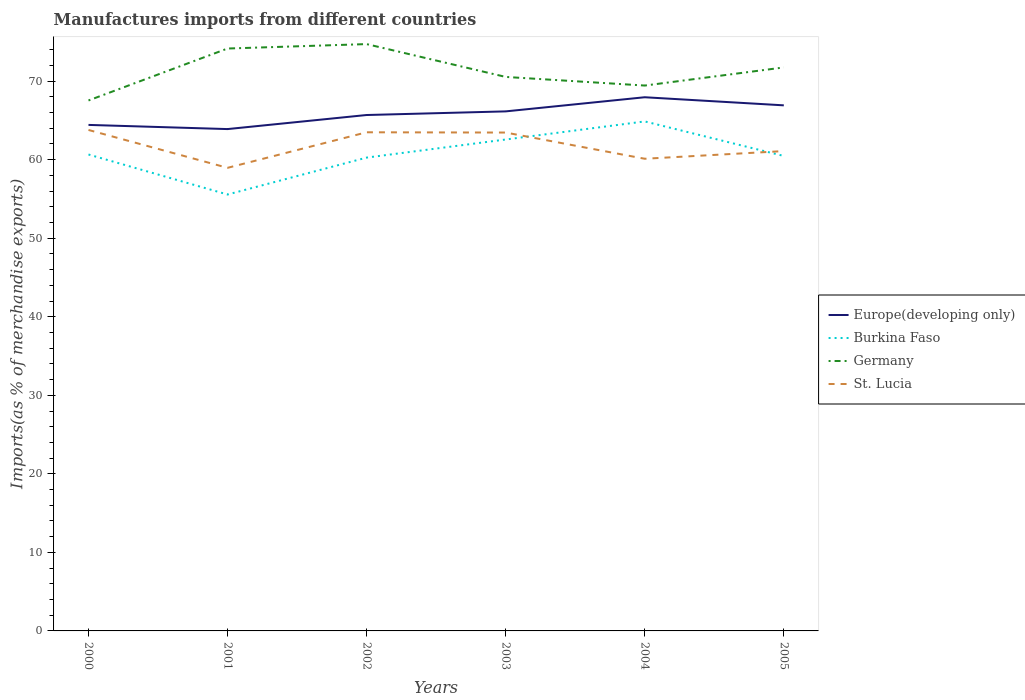How many different coloured lines are there?
Provide a succinct answer. 4. Does the line corresponding to Germany intersect with the line corresponding to Burkina Faso?
Offer a very short reply. No. Across all years, what is the maximum percentage of imports to different countries in St. Lucia?
Keep it short and to the point. 58.96. In which year was the percentage of imports to different countries in St. Lucia maximum?
Make the answer very short. 2001. What is the total percentage of imports to different countries in Germany in the graph?
Ensure brevity in your answer.  5.28. What is the difference between the highest and the second highest percentage of imports to different countries in Burkina Faso?
Ensure brevity in your answer.  9.31. Is the percentage of imports to different countries in Germany strictly greater than the percentage of imports to different countries in Burkina Faso over the years?
Provide a succinct answer. No. How many years are there in the graph?
Offer a terse response. 6. What is the difference between two consecutive major ticks on the Y-axis?
Keep it short and to the point. 10. Are the values on the major ticks of Y-axis written in scientific E-notation?
Your answer should be compact. No. How many legend labels are there?
Ensure brevity in your answer.  4. How are the legend labels stacked?
Keep it short and to the point. Vertical. What is the title of the graph?
Your answer should be very brief. Manufactures imports from different countries. What is the label or title of the X-axis?
Make the answer very short. Years. What is the label or title of the Y-axis?
Make the answer very short. Imports(as % of merchandise exports). What is the Imports(as % of merchandise exports) of Europe(developing only) in 2000?
Offer a terse response. 64.43. What is the Imports(as % of merchandise exports) in Burkina Faso in 2000?
Ensure brevity in your answer.  60.66. What is the Imports(as % of merchandise exports) in Germany in 2000?
Your answer should be compact. 67.54. What is the Imports(as % of merchandise exports) of St. Lucia in 2000?
Your response must be concise. 63.78. What is the Imports(as % of merchandise exports) of Europe(developing only) in 2001?
Your answer should be very brief. 63.9. What is the Imports(as % of merchandise exports) in Burkina Faso in 2001?
Provide a succinct answer. 55.56. What is the Imports(as % of merchandise exports) in Germany in 2001?
Your response must be concise. 74.15. What is the Imports(as % of merchandise exports) in St. Lucia in 2001?
Give a very brief answer. 58.96. What is the Imports(as % of merchandise exports) of Europe(developing only) in 2002?
Give a very brief answer. 65.69. What is the Imports(as % of merchandise exports) in Burkina Faso in 2002?
Make the answer very short. 60.26. What is the Imports(as % of merchandise exports) in Germany in 2002?
Offer a very short reply. 74.72. What is the Imports(as % of merchandise exports) of St. Lucia in 2002?
Your answer should be very brief. 63.49. What is the Imports(as % of merchandise exports) of Europe(developing only) in 2003?
Keep it short and to the point. 66.15. What is the Imports(as % of merchandise exports) of Burkina Faso in 2003?
Offer a terse response. 62.57. What is the Imports(as % of merchandise exports) of Germany in 2003?
Your answer should be compact. 70.54. What is the Imports(as % of merchandise exports) in St. Lucia in 2003?
Provide a short and direct response. 63.45. What is the Imports(as % of merchandise exports) of Europe(developing only) in 2004?
Offer a terse response. 67.95. What is the Imports(as % of merchandise exports) in Burkina Faso in 2004?
Give a very brief answer. 64.87. What is the Imports(as % of merchandise exports) in Germany in 2004?
Provide a short and direct response. 69.44. What is the Imports(as % of merchandise exports) of St. Lucia in 2004?
Give a very brief answer. 60.12. What is the Imports(as % of merchandise exports) of Europe(developing only) in 2005?
Your answer should be very brief. 66.92. What is the Imports(as % of merchandise exports) in Burkina Faso in 2005?
Keep it short and to the point. 60.47. What is the Imports(as % of merchandise exports) in Germany in 2005?
Make the answer very short. 71.74. What is the Imports(as % of merchandise exports) in St. Lucia in 2005?
Your answer should be compact. 61.1. Across all years, what is the maximum Imports(as % of merchandise exports) of Europe(developing only)?
Make the answer very short. 67.95. Across all years, what is the maximum Imports(as % of merchandise exports) of Burkina Faso?
Provide a short and direct response. 64.87. Across all years, what is the maximum Imports(as % of merchandise exports) in Germany?
Ensure brevity in your answer.  74.72. Across all years, what is the maximum Imports(as % of merchandise exports) of St. Lucia?
Give a very brief answer. 63.78. Across all years, what is the minimum Imports(as % of merchandise exports) of Europe(developing only)?
Provide a succinct answer. 63.9. Across all years, what is the minimum Imports(as % of merchandise exports) of Burkina Faso?
Your answer should be compact. 55.56. Across all years, what is the minimum Imports(as % of merchandise exports) of Germany?
Give a very brief answer. 67.54. Across all years, what is the minimum Imports(as % of merchandise exports) of St. Lucia?
Your response must be concise. 58.96. What is the total Imports(as % of merchandise exports) of Europe(developing only) in the graph?
Make the answer very short. 395.02. What is the total Imports(as % of merchandise exports) in Burkina Faso in the graph?
Your answer should be compact. 364.4. What is the total Imports(as % of merchandise exports) in Germany in the graph?
Ensure brevity in your answer.  428.13. What is the total Imports(as % of merchandise exports) in St. Lucia in the graph?
Provide a succinct answer. 370.9. What is the difference between the Imports(as % of merchandise exports) in Europe(developing only) in 2000 and that in 2001?
Your answer should be very brief. 0.53. What is the difference between the Imports(as % of merchandise exports) in Burkina Faso in 2000 and that in 2001?
Provide a succinct answer. 5.1. What is the difference between the Imports(as % of merchandise exports) of Germany in 2000 and that in 2001?
Your response must be concise. -6.61. What is the difference between the Imports(as % of merchandise exports) in St. Lucia in 2000 and that in 2001?
Offer a very short reply. 4.82. What is the difference between the Imports(as % of merchandise exports) of Europe(developing only) in 2000 and that in 2002?
Your answer should be compact. -1.26. What is the difference between the Imports(as % of merchandise exports) in Burkina Faso in 2000 and that in 2002?
Make the answer very short. 0.39. What is the difference between the Imports(as % of merchandise exports) of Germany in 2000 and that in 2002?
Ensure brevity in your answer.  -7.18. What is the difference between the Imports(as % of merchandise exports) in St. Lucia in 2000 and that in 2002?
Ensure brevity in your answer.  0.3. What is the difference between the Imports(as % of merchandise exports) in Europe(developing only) in 2000 and that in 2003?
Your answer should be very brief. -1.72. What is the difference between the Imports(as % of merchandise exports) in Burkina Faso in 2000 and that in 2003?
Offer a terse response. -1.91. What is the difference between the Imports(as % of merchandise exports) of Germany in 2000 and that in 2003?
Provide a succinct answer. -3. What is the difference between the Imports(as % of merchandise exports) of St. Lucia in 2000 and that in 2003?
Offer a very short reply. 0.33. What is the difference between the Imports(as % of merchandise exports) of Europe(developing only) in 2000 and that in 2004?
Your answer should be compact. -3.52. What is the difference between the Imports(as % of merchandise exports) in Burkina Faso in 2000 and that in 2004?
Offer a terse response. -4.21. What is the difference between the Imports(as % of merchandise exports) of Germany in 2000 and that in 2004?
Provide a succinct answer. -1.9. What is the difference between the Imports(as % of merchandise exports) in St. Lucia in 2000 and that in 2004?
Your answer should be compact. 3.67. What is the difference between the Imports(as % of merchandise exports) of Europe(developing only) in 2000 and that in 2005?
Your answer should be compact. -2.49. What is the difference between the Imports(as % of merchandise exports) in Burkina Faso in 2000 and that in 2005?
Ensure brevity in your answer.  0.19. What is the difference between the Imports(as % of merchandise exports) of Germany in 2000 and that in 2005?
Keep it short and to the point. -4.21. What is the difference between the Imports(as % of merchandise exports) of St. Lucia in 2000 and that in 2005?
Your answer should be very brief. 2.69. What is the difference between the Imports(as % of merchandise exports) of Europe(developing only) in 2001 and that in 2002?
Your response must be concise. -1.79. What is the difference between the Imports(as % of merchandise exports) in Burkina Faso in 2001 and that in 2002?
Provide a succinct answer. -4.7. What is the difference between the Imports(as % of merchandise exports) of Germany in 2001 and that in 2002?
Ensure brevity in your answer.  -0.56. What is the difference between the Imports(as % of merchandise exports) of St. Lucia in 2001 and that in 2002?
Keep it short and to the point. -4.53. What is the difference between the Imports(as % of merchandise exports) of Europe(developing only) in 2001 and that in 2003?
Offer a terse response. -2.25. What is the difference between the Imports(as % of merchandise exports) in Burkina Faso in 2001 and that in 2003?
Provide a short and direct response. -7. What is the difference between the Imports(as % of merchandise exports) of Germany in 2001 and that in 2003?
Your answer should be compact. 3.62. What is the difference between the Imports(as % of merchandise exports) of St. Lucia in 2001 and that in 2003?
Your response must be concise. -4.49. What is the difference between the Imports(as % of merchandise exports) of Europe(developing only) in 2001 and that in 2004?
Make the answer very short. -4.05. What is the difference between the Imports(as % of merchandise exports) in Burkina Faso in 2001 and that in 2004?
Keep it short and to the point. -9.31. What is the difference between the Imports(as % of merchandise exports) of Germany in 2001 and that in 2004?
Provide a succinct answer. 4.71. What is the difference between the Imports(as % of merchandise exports) of St. Lucia in 2001 and that in 2004?
Your answer should be very brief. -1.16. What is the difference between the Imports(as % of merchandise exports) of Europe(developing only) in 2001 and that in 2005?
Your response must be concise. -3.02. What is the difference between the Imports(as % of merchandise exports) in Burkina Faso in 2001 and that in 2005?
Your answer should be compact. -4.91. What is the difference between the Imports(as % of merchandise exports) in Germany in 2001 and that in 2005?
Keep it short and to the point. 2.41. What is the difference between the Imports(as % of merchandise exports) in St. Lucia in 2001 and that in 2005?
Provide a succinct answer. -2.13. What is the difference between the Imports(as % of merchandise exports) of Europe(developing only) in 2002 and that in 2003?
Your answer should be compact. -0.46. What is the difference between the Imports(as % of merchandise exports) of Burkina Faso in 2002 and that in 2003?
Give a very brief answer. -2.3. What is the difference between the Imports(as % of merchandise exports) of Germany in 2002 and that in 2003?
Offer a very short reply. 4.18. What is the difference between the Imports(as % of merchandise exports) of St. Lucia in 2002 and that in 2003?
Offer a very short reply. 0.03. What is the difference between the Imports(as % of merchandise exports) of Europe(developing only) in 2002 and that in 2004?
Provide a succinct answer. -2.26. What is the difference between the Imports(as % of merchandise exports) in Burkina Faso in 2002 and that in 2004?
Provide a succinct answer. -4.61. What is the difference between the Imports(as % of merchandise exports) of Germany in 2002 and that in 2004?
Offer a very short reply. 5.28. What is the difference between the Imports(as % of merchandise exports) of St. Lucia in 2002 and that in 2004?
Offer a very short reply. 3.37. What is the difference between the Imports(as % of merchandise exports) of Europe(developing only) in 2002 and that in 2005?
Your answer should be compact. -1.23. What is the difference between the Imports(as % of merchandise exports) in Burkina Faso in 2002 and that in 2005?
Ensure brevity in your answer.  -0.21. What is the difference between the Imports(as % of merchandise exports) of Germany in 2002 and that in 2005?
Provide a succinct answer. 2.97. What is the difference between the Imports(as % of merchandise exports) in St. Lucia in 2002 and that in 2005?
Your answer should be compact. 2.39. What is the difference between the Imports(as % of merchandise exports) of Europe(developing only) in 2003 and that in 2004?
Give a very brief answer. -1.8. What is the difference between the Imports(as % of merchandise exports) in Burkina Faso in 2003 and that in 2004?
Make the answer very short. -2.3. What is the difference between the Imports(as % of merchandise exports) in Germany in 2003 and that in 2004?
Offer a very short reply. 1.1. What is the difference between the Imports(as % of merchandise exports) of St. Lucia in 2003 and that in 2004?
Your answer should be very brief. 3.34. What is the difference between the Imports(as % of merchandise exports) in Europe(developing only) in 2003 and that in 2005?
Your answer should be compact. -0.77. What is the difference between the Imports(as % of merchandise exports) of Burkina Faso in 2003 and that in 2005?
Give a very brief answer. 2.09. What is the difference between the Imports(as % of merchandise exports) of Germany in 2003 and that in 2005?
Provide a succinct answer. -1.21. What is the difference between the Imports(as % of merchandise exports) of St. Lucia in 2003 and that in 2005?
Offer a terse response. 2.36. What is the difference between the Imports(as % of merchandise exports) of Europe(developing only) in 2004 and that in 2005?
Your answer should be very brief. 1.03. What is the difference between the Imports(as % of merchandise exports) in Burkina Faso in 2004 and that in 2005?
Offer a terse response. 4.4. What is the difference between the Imports(as % of merchandise exports) of Germany in 2004 and that in 2005?
Your answer should be compact. -2.31. What is the difference between the Imports(as % of merchandise exports) of St. Lucia in 2004 and that in 2005?
Offer a terse response. -0.98. What is the difference between the Imports(as % of merchandise exports) of Europe(developing only) in 2000 and the Imports(as % of merchandise exports) of Burkina Faso in 2001?
Your answer should be compact. 8.86. What is the difference between the Imports(as % of merchandise exports) of Europe(developing only) in 2000 and the Imports(as % of merchandise exports) of Germany in 2001?
Provide a short and direct response. -9.73. What is the difference between the Imports(as % of merchandise exports) of Europe(developing only) in 2000 and the Imports(as % of merchandise exports) of St. Lucia in 2001?
Give a very brief answer. 5.47. What is the difference between the Imports(as % of merchandise exports) of Burkina Faso in 2000 and the Imports(as % of merchandise exports) of Germany in 2001?
Give a very brief answer. -13.49. What is the difference between the Imports(as % of merchandise exports) in Burkina Faso in 2000 and the Imports(as % of merchandise exports) in St. Lucia in 2001?
Ensure brevity in your answer.  1.7. What is the difference between the Imports(as % of merchandise exports) of Germany in 2000 and the Imports(as % of merchandise exports) of St. Lucia in 2001?
Keep it short and to the point. 8.58. What is the difference between the Imports(as % of merchandise exports) in Europe(developing only) in 2000 and the Imports(as % of merchandise exports) in Burkina Faso in 2002?
Your answer should be compact. 4.16. What is the difference between the Imports(as % of merchandise exports) of Europe(developing only) in 2000 and the Imports(as % of merchandise exports) of Germany in 2002?
Offer a very short reply. -10.29. What is the difference between the Imports(as % of merchandise exports) in Europe(developing only) in 2000 and the Imports(as % of merchandise exports) in St. Lucia in 2002?
Ensure brevity in your answer.  0.94. What is the difference between the Imports(as % of merchandise exports) in Burkina Faso in 2000 and the Imports(as % of merchandise exports) in Germany in 2002?
Keep it short and to the point. -14.06. What is the difference between the Imports(as % of merchandise exports) in Burkina Faso in 2000 and the Imports(as % of merchandise exports) in St. Lucia in 2002?
Give a very brief answer. -2.83. What is the difference between the Imports(as % of merchandise exports) in Germany in 2000 and the Imports(as % of merchandise exports) in St. Lucia in 2002?
Your response must be concise. 4.05. What is the difference between the Imports(as % of merchandise exports) in Europe(developing only) in 2000 and the Imports(as % of merchandise exports) in Burkina Faso in 2003?
Give a very brief answer. 1.86. What is the difference between the Imports(as % of merchandise exports) in Europe(developing only) in 2000 and the Imports(as % of merchandise exports) in Germany in 2003?
Give a very brief answer. -6.11. What is the difference between the Imports(as % of merchandise exports) in Europe(developing only) in 2000 and the Imports(as % of merchandise exports) in St. Lucia in 2003?
Give a very brief answer. 0.97. What is the difference between the Imports(as % of merchandise exports) of Burkina Faso in 2000 and the Imports(as % of merchandise exports) of Germany in 2003?
Provide a succinct answer. -9.88. What is the difference between the Imports(as % of merchandise exports) in Burkina Faso in 2000 and the Imports(as % of merchandise exports) in St. Lucia in 2003?
Provide a short and direct response. -2.79. What is the difference between the Imports(as % of merchandise exports) in Germany in 2000 and the Imports(as % of merchandise exports) in St. Lucia in 2003?
Ensure brevity in your answer.  4.08. What is the difference between the Imports(as % of merchandise exports) of Europe(developing only) in 2000 and the Imports(as % of merchandise exports) of Burkina Faso in 2004?
Ensure brevity in your answer.  -0.44. What is the difference between the Imports(as % of merchandise exports) of Europe(developing only) in 2000 and the Imports(as % of merchandise exports) of Germany in 2004?
Offer a very short reply. -5.01. What is the difference between the Imports(as % of merchandise exports) of Europe(developing only) in 2000 and the Imports(as % of merchandise exports) of St. Lucia in 2004?
Offer a terse response. 4.31. What is the difference between the Imports(as % of merchandise exports) in Burkina Faso in 2000 and the Imports(as % of merchandise exports) in Germany in 2004?
Your answer should be compact. -8.78. What is the difference between the Imports(as % of merchandise exports) of Burkina Faso in 2000 and the Imports(as % of merchandise exports) of St. Lucia in 2004?
Your answer should be very brief. 0.54. What is the difference between the Imports(as % of merchandise exports) of Germany in 2000 and the Imports(as % of merchandise exports) of St. Lucia in 2004?
Ensure brevity in your answer.  7.42. What is the difference between the Imports(as % of merchandise exports) in Europe(developing only) in 2000 and the Imports(as % of merchandise exports) in Burkina Faso in 2005?
Offer a terse response. 3.95. What is the difference between the Imports(as % of merchandise exports) of Europe(developing only) in 2000 and the Imports(as % of merchandise exports) of Germany in 2005?
Make the answer very short. -7.32. What is the difference between the Imports(as % of merchandise exports) of Europe(developing only) in 2000 and the Imports(as % of merchandise exports) of St. Lucia in 2005?
Keep it short and to the point. 3.33. What is the difference between the Imports(as % of merchandise exports) of Burkina Faso in 2000 and the Imports(as % of merchandise exports) of Germany in 2005?
Offer a terse response. -11.09. What is the difference between the Imports(as % of merchandise exports) of Burkina Faso in 2000 and the Imports(as % of merchandise exports) of St. Lucia in 2005?
Provide a succinct answer. -0.44. What is the difference between the Imports(as % of merchandise exports) in Germany in 2000 and the Imports(as % of merchandise exports) in St. Lucia in 2005?
Keep it short and to the point. 6.44. What is the difference between the Imports(as % of merchandise exports) in Europe(developing only) in 2001 and the Imports(as % of merchandise exports) in Burkina Faso in 2002?
Provide a succinct answer. 3.63. What is the difference between the Imports(as % of merchandise exports) in Europe(developing only) in 2001 and the Imports(as % of merchandise exports) in Germany in 2002?
Keep it short and to the point. -10.82. What is the difference between the Imports(as % of merchandise exports) of Europe(developing only) in 2001 and the Imports(as % of merchandise exports) of St. Lucia in 2002?
Your answer should be very brief. 0.41. What is the difference between the Imports(as % of merchandise exports) of Burkina Faso in 2001 and the Imports(as % of merchandise exports) of Germany in 2002?
Your answer should be very brief. -19.15. What is the difference between the Imports(as % of merchandise exports) of Burkina Faso in 2001 and the Imports(as % of merchandise exports) of St. Lucia in 2002?
Provide a succinct answer. -7.92. What is the difference between the Imports(as % of merchandise exports) of Germany in 2001 and the Imports(as % of merchandise exports) of St. Lucia in 2002?
Give a very brief answer. 10.66. What is the difference between the Imports(as % of merchandise exports) of Europe(developing only) in 2001 and the Imports(as % of merchandise exports) of Burkina Faso in 2003?
Your answer should be very brief. 1.33. What is the difference between the Imports(as % of merchandise exports) in Europe(developing only) in 2001 and the Imports(as % of merchandise exports) in Germany in 2003?
Your response must be concise. -6.64. What is the difference between the Imports(as % of merchandise exports) of Europe(developing only) in 2001 and the Imports(as % of merchandise exports) of St. Lucia in 2003?
Provide a succinct answer. 0.44. What is the difference between the Imports(as % of merchandise exports) of Burkina Faso in 2001 and the Imports(as % of merchandise exports) of Germany in 2003?
Your answer should be compact. -14.97. What is the difference between the Imports(as % of merchandise exports) of Burkina Faso in 2001 and the Imports(as % of merchandise exports) of St. Lucia in 2003?
Provide a short and direct response. -7.89. What is the difference between the Imports(as % of merchandise exports) in Germany in 2001 and the Imports(as % of merchandise exports) in St. Lucia in 2003?
Ensure brevity in your answer.  10.7. What is the difference between the Imports(as % of merchandise exports) in Europe(developing only) in 2001 and the Imports(as % of merchandise exports) in Burkina Faso in 2004?
Offer a terse response. -0.97. What is the difference between the Imports(as % of merchandise exports) of Europe(developing only) in 2001 and the Imports(as % of merchandise exports) of Germany in 2004?
Offer a very short reply. -5.54. What is the difference between the Imports(as % of merchandise exports) of Europe(developing only) in 2001 and the Imports(as % of merchandise exports) of St. Lucia in 2004?
Offer a very short reply. 3.78. What is the difference between the Imports(as % of merchandise exports) in Burkina Faso in 2001 and the Imports(as % of merchandise exports) in Germany in 2004?
Your answer should be compact. -13.87. What is the difference between the Imports(as % of merchandise exports) in Burkina Faso in 2001 and the Imports(as % of merchandise exports) in St. Lucia in 2004?
Your answer should be very brief. -4.55. What is the difference between the Imports(as % of merchandise exports) of Germany in 2001 and the Imports(as % of merchandise exports) of St. Lucia in 2004?
Make the answer very short. 14.04. What is the difference between the Imports(as % of merchandise exports) of Europe(developing only) in 2001 and the Imports(as % of merchandise exports) of Burkina Faso in 2005?
Offer a terse response. 3.42. What is the difference between the Imports(as % of merchandise exports) of Europe(developing only) in 2001 and the Imports(as % of merchandise exports) of Germany in 2005?
Your answer should be very brief. -7.85. What is the difference between the Imports(as % of merchandise exports) in Europe(developing only) in 2001 and the Imports(as % of merchandise exports) in St. Lucia in 2005?
Offer a very short reply. 2.8. What is the difference between the Imports(as % of merchandise exports) in Burkina Faso in 2001 and the Imports(as % of merchandise exports) in Germany in 2005?
Provide a succinct answer. -16.18. What is the difference between the Imports(as % of merchandise exports) of Burkina Faso in 2001 and the Imports(as % of merchandise exports) of St. Lucia in 2005?
Give a very brief answer. -5.53. What is the difference between the Imports(as % of merchandise exports) of Germany in 2001 and the Imports(as % of merchandise exports) of St. Lucia in 2005?
Ensure brevity in your answer.  13.06. What is the difference between the Imports(as % of merchandise exports) in Europe(developing only) in 2002 and the Imports(as % of merchandise exports) in Burkina Faso in 2003?
Your answer should be very brief. 3.12. What is the difference between the Imports(as % of merchandise exports) in Europe(developing only) in 2002 and the Imports(as % of merchandise exports) in Germany in 2003?
Make the answer very short. -4.85. What is the difference between the Imports(as % of merchandise exports) of Europe(developing only) in 2002 and the Imports(as % of merchandise exports) of St. Lucia in 2003?
Ensure brevity in your answer.  2.23. What is the difference between the Imports(as % of merchandise exports) of Burkina Faso in 2002 and the Imports(as % of merchandise exports) of Germany in 2003?
Offer a very short reply. -10.27. What is the difference between the Imports(as % of merchandise exports) in Burkina Faso in 2002 and the Imports(as % of merchandise exports) in St. Lucia in 2003?
Provide a succinct answer. -3.19. What is the difference between the Imports(as % of merchandise exports) of Germany in 2002 and the Imports(as % of merchandise exports) of St. Lucia in 2003?
Provide a succinct answer. 11.26. What is the difference between the Imports(as % of merchandise exports) in Europe(developing only) in 2002 and the Imports(as % of merchandise exports) in Burkina Faso in 2004?
Your answer should be compact. 0.82. What is the difference between the Imports(as % of merchandise exports) in Europe(developing only) in 2002 and the Imports(as % of merchandise exports) in Germany in 2004?
Make the answer very short. -3.75. What is the difference between the Imports(as % of merchandise exports) in Europe(developing only) in 2002 and the Imports(as % of merchandise exports) in St. Lucia in 2004?
Offer a very short reply. 5.57. What is the difference between the Imports(as % of merchandise exports) of Burkina Faso in 2002 and the Imports(as % of merchandise exports) of Germany in 2004?
Keep it short and to the point. -9.17. What is the difference between the Imports(as % of merchandise exports) in Burkina Faso in 2002 and the Imports(as % of merchandise exports) in St. Lucia in 2004?
Offer a terse response. 0.15. What is the difference between the Imports(as % of merchandise exports) in Germany in 2002 and the Imports(as % of merchandise exports) in St. Lucia in 2004?
Provide a short and direct response. 14.6. What is the difference between the Imports(as % of merchandise exports) in Europe(developing only) in 2002 and the Imports(as % of merchandise exports) in Burkina Faso in 2005?
Offer a very short reply. 5.21. What is the difference between the Imports(as % of merchandise exports) of Europe(developing only) in 2002 and the Imports(as % of merchandise exports) of Germany in 2005?
Your answer should be very brief. -6.06. What is the difference between the Imports(as % of merchandise exports) of Europe(developing only) in 2002 and the Imports(as % of merchandise exports) of St. Lucia in 2005?
Provide a succinct answer. 4.59. What is the difference between the Imports(as % of merchandise exports) of Burkina Faso in 2002 and the Imports(as % of merchandise exports) of Germany in 2005?
Your answer should be very brief. -11.48. What is the difference between the Imports(as % of merchandise exports) of Burkina Faso in 2002 and the Imports(as % of merchandise exports) of St. Lucia in 2005?
Make the answer very short. -0.83. What is the difference between the Imports(as % of merchandise exports) in Germany in 2002 and the Imports(as % of merchandise exports) in St. Lucia in 2005?
Make the answer very short. 13.62. What is the difference between the Imports(as % of merchandise exports) of Europe(developing only) in 2003 and the Imports(as % of merchandise exports) of Burkina Faso in 2004?
Make the answer very short. 1.28. What is the difference between the Imports(as % of merchandise exports) in Europe(developing only) in 2003 and the Imports(as % of merchandise exports) in Germany in 2004?
Your response must be concise. -3.29. What is the difference between the Imports(as % of merchandise exports) in Europe(developing only) in 2003 and the Imports(as % of merchandise exports) in St. Lucia in 2004?
Give a very brief answer. 6.03. What is the difference between the Imports(as % of merchandise exports) of Burkina Faso in 2003 and the Imports(as % of merchandise exports) of Germany in 2004?
Your answer should be compact. -6.87. What is the difference between the Imports(as % of merchandise exports) in Burkina Faso in 2003 and the Imports(as % of merchandise exports) in St. Lucia in 2004?
Provide a succinct answer. 2.45. What is the difference between the Imports(as % of merchandise exports) of Germany in 2003 and the Imports(as % of merchandise exports) of St. Lucia in 2004?
Ensure brevity in your answer.  10.42. What is the difference between the Imports(as % of merchandise exports) of Europe(developing only) in 2003 and the Imports(as % of merchandise exports) of Burkina Faso in 2005?
Your answer should be very brief. 5.67. What is the difference between the Imports(as % of merchandise exports) of Europe(developing only) in 2003 and the Imports(as % of merchandise exports) of Germany in 2005?
Your answer should be very brief. -5.6. What is the difference between the Imports(as % of merchandise exports) of Europe(developing only) in 2003 and the Imports(as % of merchandise exports) of St. Lucia in 2005?
Offer a very short reply. 5.05. What is the difference between the Imports(as % of merchandise exports) in Burkina Faso in 2003 and the Imports(as % of merchandise exports) in Germany in 2005?
Make the answer very short. -9.18. What is the difference between the Imports(as % of merchandise exports) of Burkina Faso in 2003 and the Imports(as % of merchandise exports) of St. Lucia in 2005?
Provide a short and direct response. 1.47. What is the difference between the Imports(as % of merchandise exports) of Germany in 2003 and the Imports(as % of merchandise exports) of St. Lucia in 2005?
Your answer should be compact. 9.44. What is the difference between the Imports(as % of merchandise exports) of Europe(developing only) in 2004 and the Imports(as % of merchandise exports) of Burkina Faso in 2005?
Offer a terse response. 7.47. What is the difference between the Imports(as % of merchandise exports) of Europe(developing only) in 2004 and the Imports(as % of merchandise exports) of Germany in 2005?
Keep it short and to the point. -3.8. What is the difference between the Imports(as % of merchandise exports) in Europe(developing only) in 2004 and the Imports(as % of merchandise exports) in St. Lucia in 2005?
Keep it short and to the point. 6.85. What is the difference between the Imports(as % of merchandise exports) of Burkina Faso in 2004 and the Imports(as % of merchandise exports) of Germany in 2005?
Provide a short and direct response. -6.87. What is the difference between the Imports(as % of merchandise exports) of Burkina Faso in 2004 and the Imports(as % of merchandise exports) of St. Lucia in 2005?
Your response must be concise. 3.78. What is the difference between the Imports(as % of merchandise exports) of Germany in 2004 and the Imports(as % of merchandise exports) of St. Lucia in 2005?
Ensure brevity in your answer.  8.34. What is the average Imports(as % of merchandise exports) in Europe(developing only) per year?
Your answer should be compact. 65.84. What is the average Imports(as % of merchandise exports) of Burkina Faso per year?
Offer a terse response. 60.73. What is the average Imports(as % of merchandise exports) of Germany per year?
Provide a succinct answer. 71.35. What is the average Imports(as % of merchandise exports) in St. Lucia per year?
Make the answer very short. 61.82. In the year 2000, what is the difference between the Imports(as % of merchandise exports) in Europe(developing only) and Imports(as % of merchandise exports) in Burkina Faso?
Ensure brevity in your answer.  3.77. In the year 2000, what is the difference between the Imports(as % of merchandise exports) in Europe(developing only) and Imports(as % of merchandise exports) in Germany?
Provide a succinct answer. -3.11. In the year 2000, what is the difference between the Imports(as % of merchandise exports) of Europe(developing only) and Imports(as % of merchandise exports) of St. Lucia?
Your response must be concise. 0.64. In the year 2000, what is the difference between the Imports(as % of merchandise exports) in Burkina Faso and Imports(as % of merchandise exports) in Germany?
Keep it short and to the point. -6.88. In the year 2000, what is the difference between the Imports(as % of merchandise exports) in Burkina Faso and Imports(as % of merchandise exports) in St. Lucia?
Offer a terse response. -3.12. In the year 2000, what is the difference between the Imports(as % of merchandise exports) of Germany and Imports(as % of merchandise exports) of St. Lucia?
Provide a succinct answer. 3.75. In the year 2001, what is the difference between the Imports(as % of merchandise exports) in Europe(developing only) and Imports(as % of merchandise exports) in Burkina Faso?
Your answer should be very brief. 8.33. In the year 2001, what is the difference between the Imports(as % of merchandise exports) of Europe(developing only) and Imports(as % of merchandise exports) of Germany?
Your response must be concise. -10.26. In the year 2001, what is the difference between the Imports(as % of merchandise exports) in Europe(developing only) and Imports(as % of merchandise exports) in St. Lucia?
Ensure brevity in your answer.  4.93. In the year 2001, what is the difference between the Imports(as % of merchandise exports) of Burkina Faso and Imports(as % of merchandise exports) of Germany?
Make the answer very short. -18.59. In the year 2001, what is the difference between the Imports(as % of merchandise exports) in Burkina Faso and Imports(as % of merchandise exports) in St. Lucia?
Offer a terse response. -3.4. In the year 2001, what is the difference between the Imports(as % of merchandise exports) of Germany and Imports(as % of merchandise exports) of St. Lucia?
Give a very brief answer. 15.19. In the year 2002, what is the difference between the Imports(as % of merchandise exports) of Europe(developing only) and Imports(as % of merchandise exports) of Burkina Faso?
Offer a terse response. 5.42. In the year 2002, what is the difference between the Imports(as % of merchandise exports) in Europe(developing only) and Imports(as % of merchandise exports) in Germany?
Keep it short and to the point. -9.03. In the year 2002, what is the difference between the Imports(as % of merchandise exports) of Europe(developing only) and Imports(as % of merchandise exports) of St. Lucia?
Ensure brevity in your answer.  2.2. In the year 2002, what is the difference between the Imports(as % of merchandise exports) in Burkina Faso and Imports(as % of merchandise exports) in Germany?
Your response must be concise. -14.45. In the year 2002, what is the difference between the Imports(as % of merchandise exports) in Burkina Faso and Imports(as % of merchandise exports) in St. Lucia?
Give a very brief answer. -3.22. In the year 2002, what is the difference between the Imports(as % of merchandise exports) in Germany and Imports(as % of merchandise exports) in St. Lucia?
Ensure brevity in your answer.  11.23. In the year 2003, what is the difference between the Imports(as % of merchandise exports) in Europe(developing only) and Imports(as % of merchandise exports) in Burkina Faso?
Ensure brevity in your answer.  3.58. In the year 2003, what is the difference between the Imports(as % of merchandise exports) in Europe(developing only) and Imports(as % of merchandise exports) in Germany?
Offer a terse response. -4.39. In the year 2003, what is the difference between the Imports(as % of merchandise exports) of Europe(developing only) and Imports(as % of merchandise exports) of St. Lucia?
Offer a terse response. 2.69. In the year 2003, what is the difference between the Imports(as % of merchandise exports) of Burkina Faso and Imports(as % of merchandise exports) of Germany?
Give a very brief answer. -7.97. In the year 2003, what is the difference between the Imports(as % of merchandise exports) of Burkina Faso and Imports(as % of merchandise exports) of St. Lucia?
Keep it short and to the point. -0.89. In the year 2003, what is the difference between the Imports(as % of merchandise exports) of Germany and Imports(as % of merchandise exports) of St. Lucia?
Offer a very short reply. 7.08. In the year 2004, what is the difference between the Imports(as % of merchandise exports) in Europe(developing only) and Imports(as % of merchandise exports) in Burkina Faso?
Give a very brief answer. 3.08. In the year 2004, what is the difference between the Imports(as % of merchandise exports) in Europe(developing only) and Imports(as % of merchandise exports) in Germany?
Ensure brevity in your answer.  -1.49. In the year 2004, what is the difference between the Imports(as % of merchandise exports) in Europe(developing only) and Imports(as % of merchandise exports) in St. Lucia?
Keep it short and to the point. 7.83. In the year 2004, what is the difference between the Imports(as % of merchandise exports) in Burkina Faso and Imports(as % of merchandise exports) in Germany?
Give a very brief answer. -4.57. In the year 2004, what is the difference between the Imports(as % of merchandise exports) of Burkina Faso and Imports(as % of merchandise exports) of St. Lucia?
Keep it short and to the point. 4.75. In the year 2004, what is the difference between the Imports(as % of merchandise exports) in Germany and Imports(as % of merchandise exports) in St. Lucia?
Keep it short and to the point. 9.32. In the year 2005, what is the difference between the Imports(as % of merchandise exports) in Europe(developing only) and Imports(as % of merchandise exports) in Burkina Faso?
Give a very brief answer. 6.44. In the year 2005, what is the difference between the Imports(as % of merchandise exports) in Europe(developing only) and Imports(as % of merchandise exports) in Germany?
Ensure brevity in your answer.  -4.83. In the year 2005, what is the difference between the Imports(as % of merchandise exports) in Europe(developing only) and Imports(as % of merchandise exports) in St. Lucia?
Offer a terse response. 5.82. In the year 2005, what is the difference between the Imports(as % of merchandise exports) in Burkina Faso and Imports(as % of merchandise exports) in Germany?
Make the answer very short. -11.27. In the year 2005, what is the difference between the Imports(as % of merchandise exports) of Burkina Faso and Imports(as % of merchandise exports) of St. Lucia?
Keep it short and to the point. -0.62. In the year 2005, what is the difference between the Imports(as % of merchandise exports) in Germany and Imports(as % of merchandise exports) in St. Lucia?
Your answer should be compact. 10.65. What is the ratio of the Imports(as % of merchandise exports) in Europe(developing only) in 2000 to that in 2001?
Offer a very short reply. 1.01. What is the ratio of the Imports(as % of merchandise exports) in Burkina Faso in 2000 to that in 2001?
Offer a very short reply. 1.09. What is the ratio of the Imports(as % of merchandise exports) in Germany in 2000 to that in 2001?
Offer a terse response. 0.91. What is the ratio of the Imports(as % of merchandise exports) of St. Lucia in 2000 to that in 2001?
Offer a very short reply. 1.08. What is the ratio of the Imports(as % of merchandise exports) in Europe(developing only) in 2000 to that in 2002?
Offer a terse response. 0.98. What is the ratio of the Imports(as % of merchandise exports) in Burkina Faso in 2000 to that in 2002?
Offer a terse response. 1.01. What is the ratio of the Imports(as % of merchandise exports) in Germany in 2000 to that in 2002?
Offer a terse response. 0.9. What is the ratio of the Imports(as % of merchandise exports) of Burkina Faso in 2000 to that in 2003?
Ensure brevity in your answer.  0.97. What is the ratio of the Imports(as % of merchandise exports) of Germany in 2000 to that in 2003?
Offer a terse response. 0.96. What is the ratio of the Imports(as % of merchandise exports) in Europe(developing only) in 2000 to that in 2004?
Provide a short and direct response. 0.95. What is the ratio of the Imports(as % of merchandise exports) of Burkina Faso in 2000 to that in 2004?
Your response must be concise. 0.94. What is the ratio of the Imports(as % of merchandise exports) of Germany in 2000 to that in 2004?
Your response must be concise. 0.97. What is the ratio of the Imports(as % of merchandise exports) of St. Lucia in 2000 to that in 2004?
Offer a terse response. 1.06. What is the ratio of the Imports(as % of merchandise exports) of Europe(developing only) in 2000 to that in 2005?
Provide a succinct answer. 0.96. What is the ratio of the Imports(as % of merchandise exports) in Germany in 2000 to that in 2005?
Offer a terse response. 0.94. What is the ratio of the Imports(as % of merchandise exports) in St. Lucia in 2000 to that in 2005?
Your answer should be compact. 1.04. What is the ratio of the Imports(as % of merchandise exports) in Europe(developing only) in 2001 to that in 2002?
Provide a succinct answer. 0.97. What is the ratio of the Imports(as % of merchandise exports) of Burkina Faso in 2001 to that in 2002?
Your answer should be very brief. 0.92. What is the ratio of the Imports(as % of merchandise exports) in Germany in 2001 to that in 2002?
Your response must be concise. 0.99. What is the ratio of the Imports(as % of merchandise exports) in St. Lucia in 2001 to that in 2002?
Provide a short and direct response. 0.93. What is the ratio of the Imports(as % of merchandise exports) in Europe(developing only) in 2001 to that in 2003?
Your answer should be very brief. 0.97. What is the ratio of the Imports(as % of merchandise exports) in Burkina Faso in 2001 to that in 2003?
Ensure brevity in your answer.  0.89. What is the ratio of the Imports(as % of merchandise exports) in Germany in 2001 to that in 2003?
Ensure brevity in your answer.  1.05. What is the ratio of the Imports(as % of merchandise exports) in St. Lucia in 2001 to that in 2003?
Give a very brief answer. 0.93. What is the ratio of the Imports(as % of merchandise exports) in Europe(developing only) in 2001 to that in 2004?
Make the answer very short. 0.94. What is the ratio of the Imports(as % of merchandise exports) of Burkina Faso in 2001 to that in 2004?
Make the answer very short. 0.86. What is the ratio of the Imports(as % of merchandise exports) in Germany in 2001 to that in 2004?
Your response must be concise. 1.07. What is the ratio of the Imports(as % of merchandise exports) in St. Lucia in 2001 to that in 2004?
Provide a short and direct response. 0.98. What is the ratio of the Imports(as % of merchandise exports) in Europe(developing only) in 2001 to that in 2005?
Your answer should be compact. 0.95. What is the ratio of the Imports(as % of merchandise exports) in Burkina Faso in 2001 to that in 2005?
Your answer should be very brief. 0.92. What is the ratio of the Imports(as % of merchandise exports) in Germany in 2001 to that in 2005?
Make the answer very short. 1.03. What is the ratio of the Imports(as % of merchandise exports) of St. Lucia in 2001 to that in 2005?
Your answer should be very brief. 0.97. What is the ratio of the Imports(as % of merchandise exports) of Burkina Faso in 2002 to that in 2003?
Provide a succinct answer. 0.96. What is the ratio of the Imports(as % of merchandise exports) in Germany in 2002 to that in 2003?
Give a very brief answer. 1.06. What is the ratio of the Imports(as % of merchandise exports) in Europe(developing only) in 2002 to that in 2004?
Your answer should be compact. 0.97. What is the ratio of the Imports(as % of merchandise exports) of Burkina Faso in 2002 to that in 2004?
Your response must be concise. 0.93. What is the ratio of the Imports(as % of merchandise exports) in Germany in 2002 to that in 2004?
Make the answer very short. 1.08. What is the ratio of the Imports(as % of merchandise exports) of St. Lucia in 2002 to that in 2004?
Make the answer very short. 1.06. What is the ratio of the Imports(as % of merchandise exports) in Europe(developing only) in 2002 to that in 2005?
Your answer should be very brief. 0.98. What is the ratio of the Imports(as % of merchandise exports) in Germany in 2002 to that in 2005?
Your answer should be very brief. 1.04. What is the ratio of the Imports(as % of merchandise exports) in St. Lucia in 2002 to that in 2005?
Provide a short and direct response. 1.04. What is the ratio of the Imports(as % of merchandise exports) in Europe(developing only) in 2003 to that in 2004?
Offer a very short reply. 0.97. What is the ratio of the Imports(as % of merchandise exports) in Burkina Faso in 2003 to that in 2004?
Your answer should be compact. 0.96. What is the ratio of the Imports(as % of merchandise exports) in Germany in 2003 to that in 2004?
Keep it short and to the point. 1.02. What is the ratio of the Imports(as % of merchandise exports) in St. Lucia in 2003 to that in 2004?
Your answer should be very brief. 1.06. What is the ratio of the Imports(as % of merchandise exports) of Europe(developing only) in 2003 to that in 2005?
Provide a short and direct response. 0.99. What is the ratio of the Imports(as % of merchandise exports) in Burkina Faso in 2003 to that in 2005?
Provide a short and direct response. 1.03. What is the ratio of the Imports(as % of merchandise exports) in Germany in 2003 to that in 2005?
Your answer should be compact. 0.98. What is the ratio of the Imports(as % of merchandise exports) in St. Lucia in 2003 to that in 2005?
Your response must be concise. 1.04. What is the ratio of the Imports(as % of merchandise exports) in Europe(developing only) in 2004 to that in 2005?
Ensure brevity in your answer.  1.02. What is the ratio of the Imports(as % of merchandise exports) in Burkina Faso in 2004 to that in 2005?
Your answer should be compact. 1.07. What is the ratio of the Imports(as % of merchandise exports) of Germany in 2004 to that in 2005?
Provide a succinct answer. 0.97. What is the ratio of the Imports(as % of merchandise exports) in St. Lucia in 2004 to that in 2005?
Make the answer very short. 0.98. What is the difference between the highest and the second highest Imports(as % of merchandise exports) in Europe(developing only)?
Offer a very short reply. 1.03. What is the difference between the highest and the second highest Imports(as % of merchandise exports) in Burkina Faso?
Ensure brevity in your answer.  2.3. What is the difference between the highest and the second highest Imports(as % of merchandise exports) of Germany?
Give a very brief answer. 0.56. What is the difference between the highest and the second highest Imports(as % of merchandise exports) in St. Lucia?
Give a very brief answer. 0.3. What is the difference between the highest and the lowest Imports(as % of merchandise exports) in Europe(developing only)?
Make the answer very short. 4.05. What is the difference between the highest and the lowest Imports(as % of merchandise exports) in Burkina Faso?
Keep it short and to the point. 9.31. What is the difference between the highest and the lowest Imports(as % of merchandise exports) in Germany?
Your answer should be compact. 7.18. What is the difference between the highest and the lowest Imports(as % of merchandise exports) in St. Lucia?
Provide a succinct answer. 4.82. 